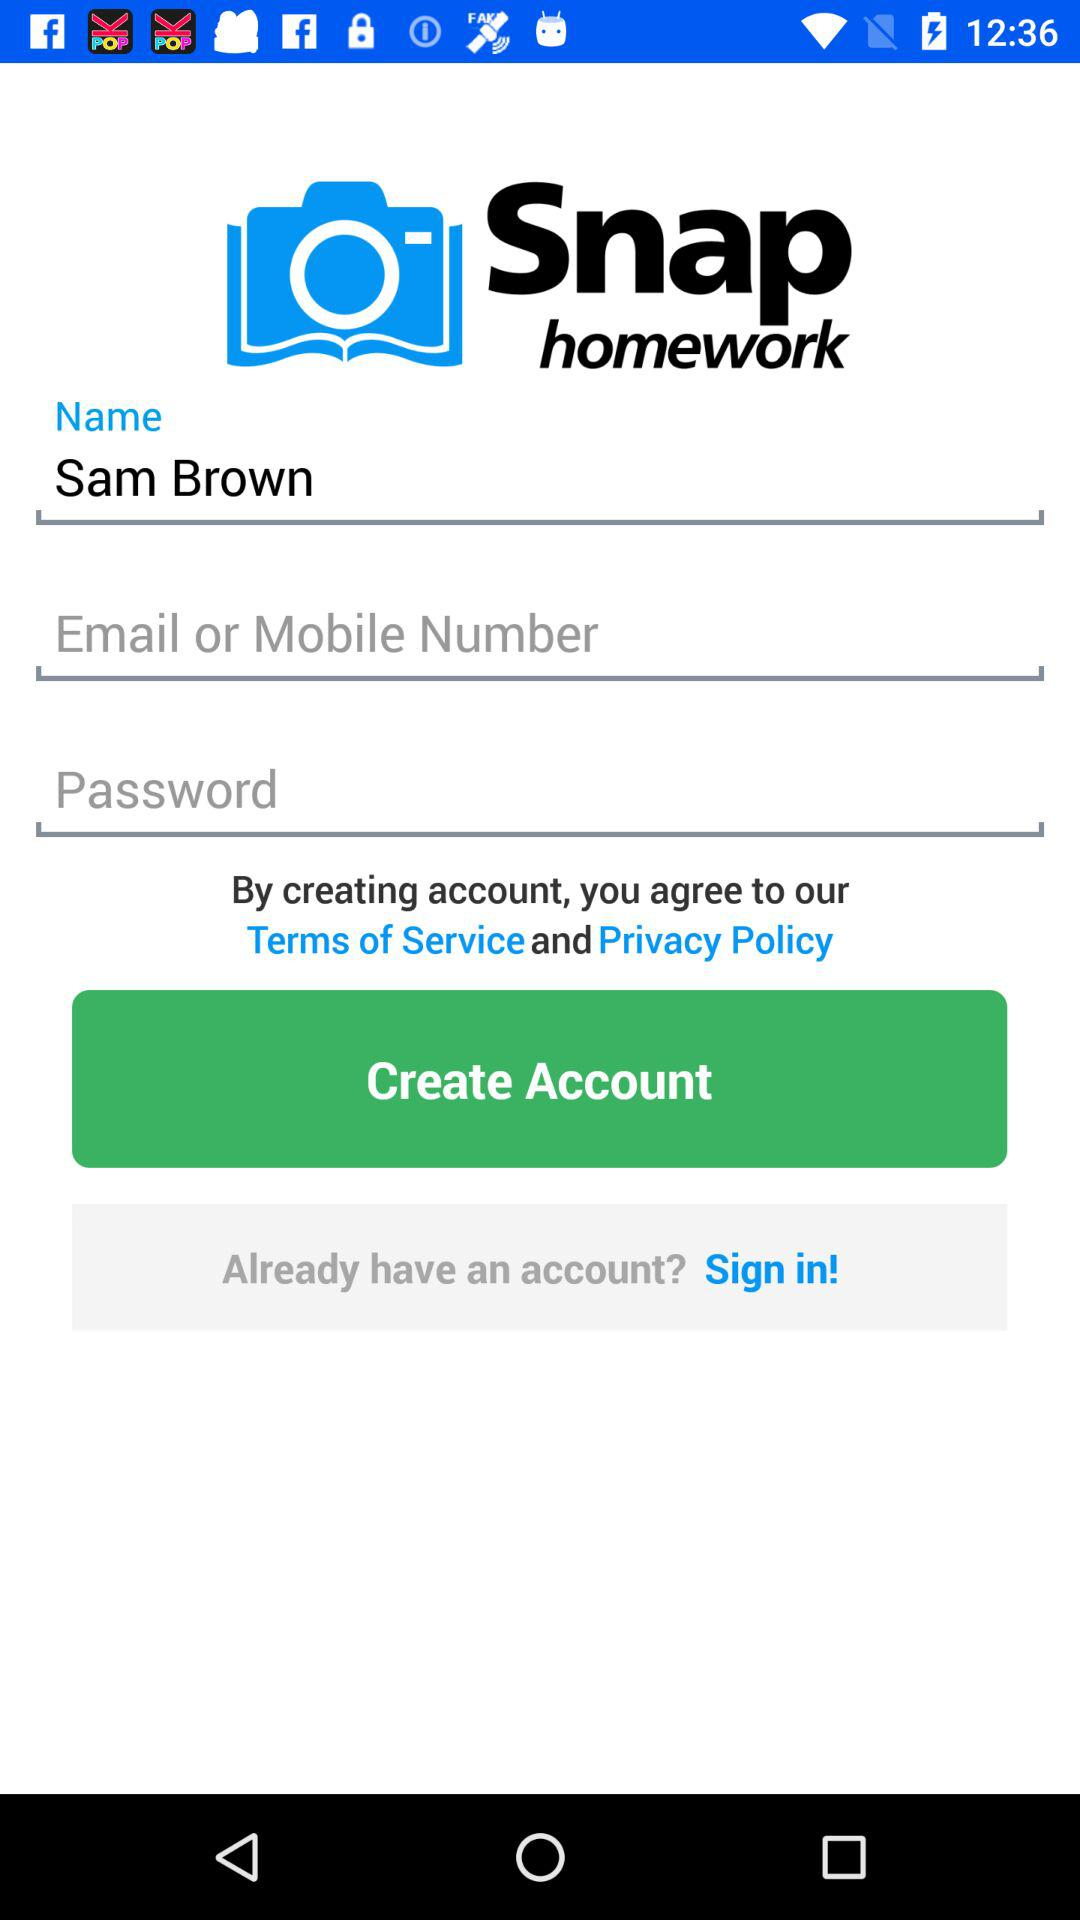What's the application name? The application name is "Snap homework". 